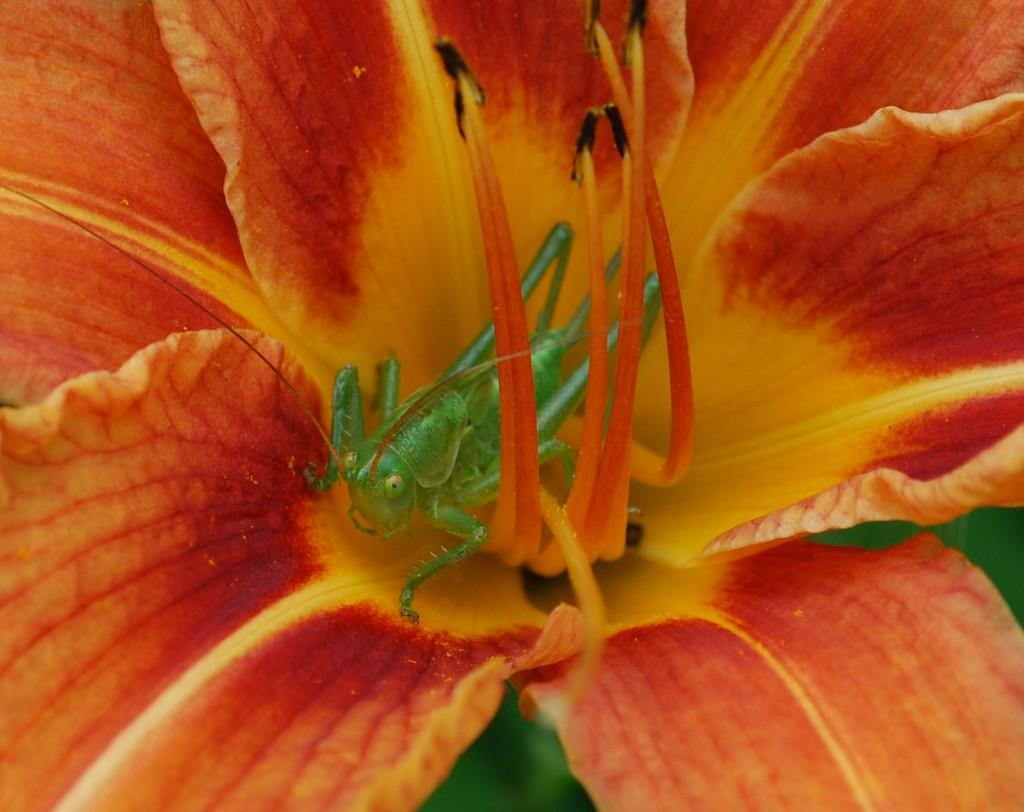What type of insect is in the image? There is a grasshopper in the image. Where is the grasshopper located? The grasshopper is on the floor. What type of flower is in the image? There is an orange and yellow flower in the image. What color is the background of the image? The background of the image is green. Can you see any children swimming in the image? There are no children or swimming activity present in the image. Is there a stamp on the grasshopper in the image? There is no stamp on the grasshopper in the image. 